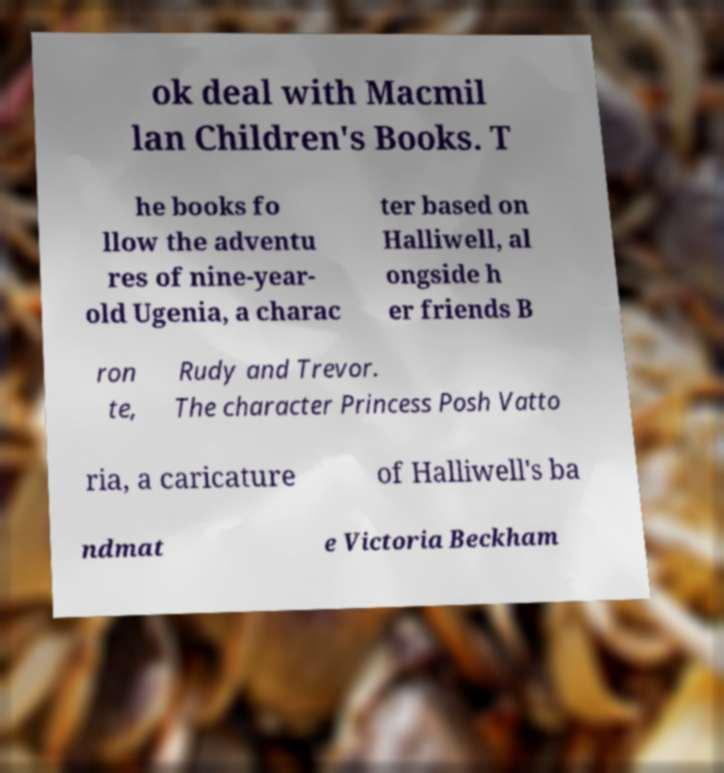What messages or text are displayed in this image? I need them in a readable, typed format. ok deal with Macmil lan Children's Books. T he books fo llow the adventu res of nine-year- old Ugenia, a charac ter based on Halliwell, al ongside h er friends B ron te, Rudy and Trevor. The character Princess Posh Vatto ria, a caricature of Halliwell's ba ndmat e Victoria Beckham 